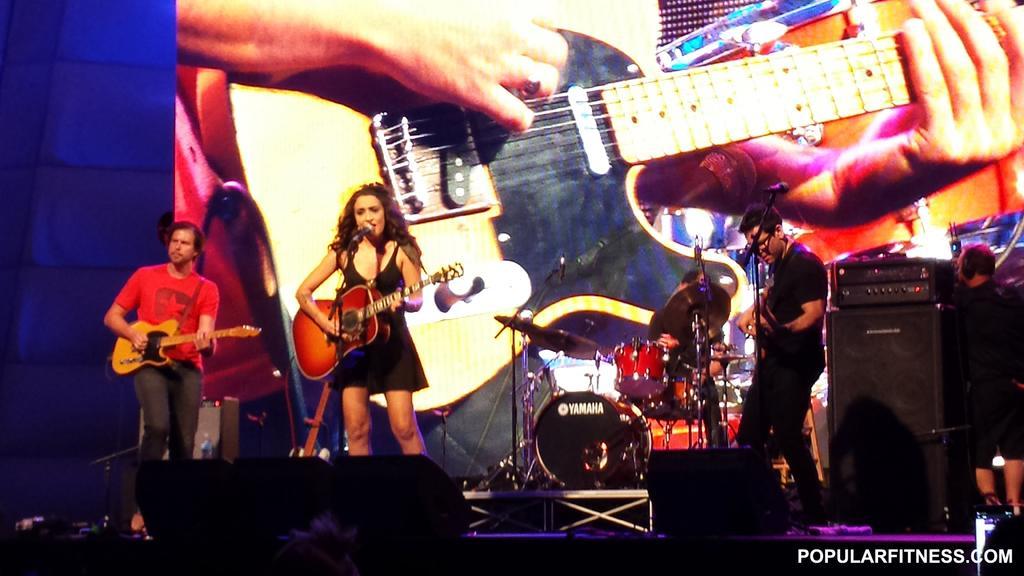Please provide a concise description of this image. In this picture there is a music band on the stage. Everyone is having a musical instrument in their hands and playing. In the background it is a speaker and projector display screen here. Everyone is having microphones in front of them. 